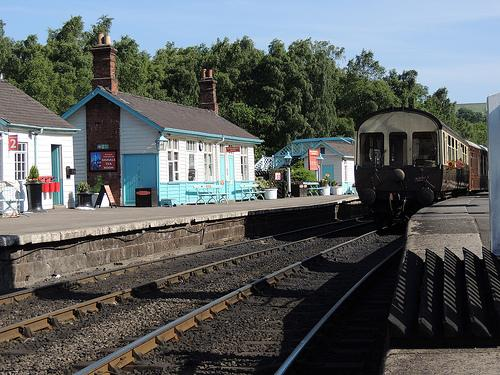Describe the environmental elements in the image related to the train tracks. There are shadows on the train tracks, black soot on the tracks, and reflection on the tracks. In a short sentence, describe the objects on the platform in the image. On the platform, there are benches, a flowerpot, a black pot, blue chairs, and a lamppost. Mention the colors and elements in the train station. There are white and blue buildings, gray platform and wall, black tile roof, green leaves on trees, and blue benches. Describe the rooftop area visible in the image. There's a gray sloped roof, a blue edge on the roof, black tile roof, and two chimneys on top of a building. Describe the position of the train on the tracks and main features. The train is situated to the right side of the tracks, and it is white and black with front windows and signs. Give a concise description of the sign elements in the image. There's a number 2 sign, small red and white signs, a sign on the ground, and signs on the side of a building. Narrate the overall ambiance of the image showing the train. The image showcases a train station with a blue sky, green trees in the background, and various buildings including some with chimneys. Write a short description of the sky in the image. The sky is blue, clear, and stretches over the train station area. Provide a brief description of the central object in the image. A train is running on the train tracks with windows and signs on its front. In a single sentence, describe the train's surroundings in the image. The train is surrounded by train tracks, a platform, a few buildings, and shadows on the tracks. 